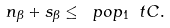<formula> <loc_0><loc_0><loc_500><loc_500>n _ { \beta } + s _ { \beta } \leq \ p o p _ { 1 } \ t C .</formula> 